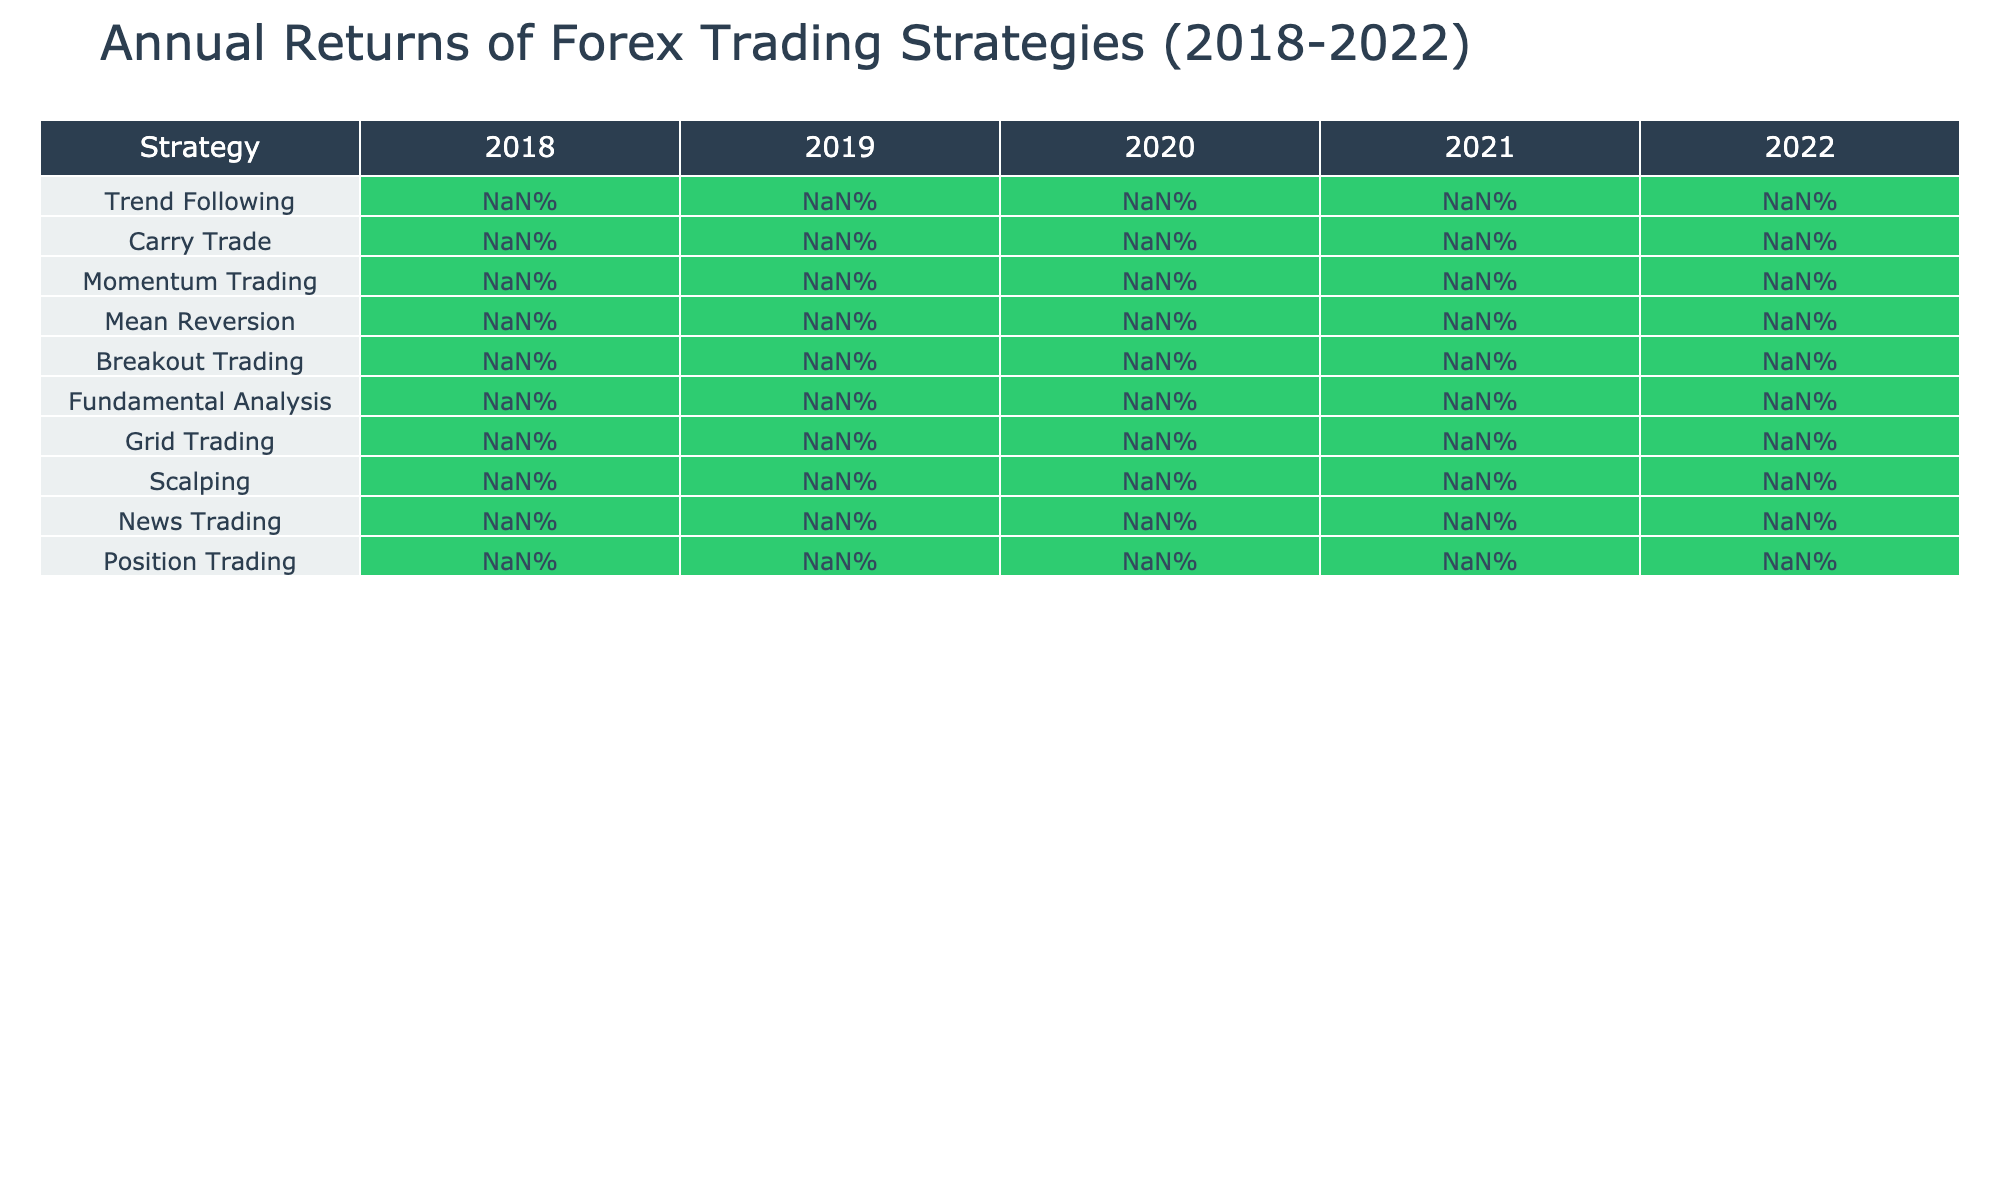What was the highest annual return in 2020? In the year 2020, the returns for each strategy are 15.3%, -5.6%, 18.9%, 9.4%, 22.1%, -3.7%, 8.1%, 16.7%, 13.5%, and 11.2%. The highest value among these is 22.1%.
Answer: 22.1% Which trading strategy consistently offered positive returns from 2018 to 2022? Checking the returns for each strategy from 2018 to 2022, only Trend Following and Breakout Trading show no negative returns any year. The others have at least one negative return.
Answer: True What was the average annual return of Carry Trade over the five years? For Carry Trade, the returns are 7.9%, 11.2%, -5.6%, 6.8%, and 4.3%. Summing them gives 24.6%, and dividing by 5 gives an average of 4.92%.
Answer: 4.92% In which year did Mean Reversion perform the worst? Looking at the returns, Mean Reversion's returns are 6.2%, 5.9%, 9.4%, 4.8%, and 3.5%. The lowest return during these years is 3.5% in 2022.
Answer: 2022 What is the difference in performance between Scalping and Breakout Trading in 2021? The returns for Scalping and Breakout Trading in 2021 are 8.3% and -1.9%, respectively. The difference is 8.3% - (-1.9%) = 8.3% + 1.9% = 10.2%.
Answer: 10.2% Which strategy had the best total return across all five years? To find this, we sum each strategy's returns: Trend Following: 42.1%, Carry Trade: 24.3%, Momentum Trading: 43.3%, Mean Reversion: 30.1%, Breakout Trading: 56.3%, Fundamental Analysis: 18.9%, Grid Trading: 26.8%, Scalping: 54.5%, News Trading: 34.5%, Position Trading: 35.3%. The highest total return is from Breakout Trading at 56.3%.
Answer: Breakout Trading How did the performance of Trend Following trend over the years? The Trend Following returns are: 12.5%, 9.8%, 15.3%, -3.2%, and 8.7%. The trend is up from 2018 to 2020, then down in 2021, but it rises again in 2022.
Answer: Mixed trend with a peak in 2020 What percentage did the Momentum Trading strategy yield in 2019? The 2019 return for Momentum Trading is directly indicated as 8.7%.
Answer: 8.7% 